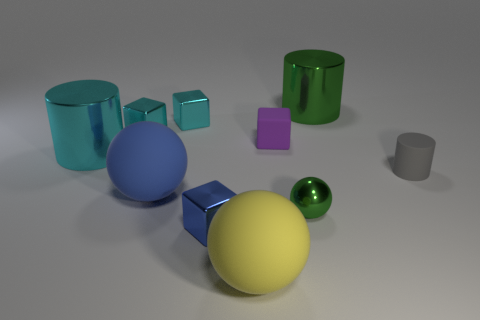The metallic ball is what color? The metallic ball appears to have a reflective surface that shows shades of green. Its reflective properties suggest it could change appearance under different lighting conditions, but in this image, it is predominantly green. 